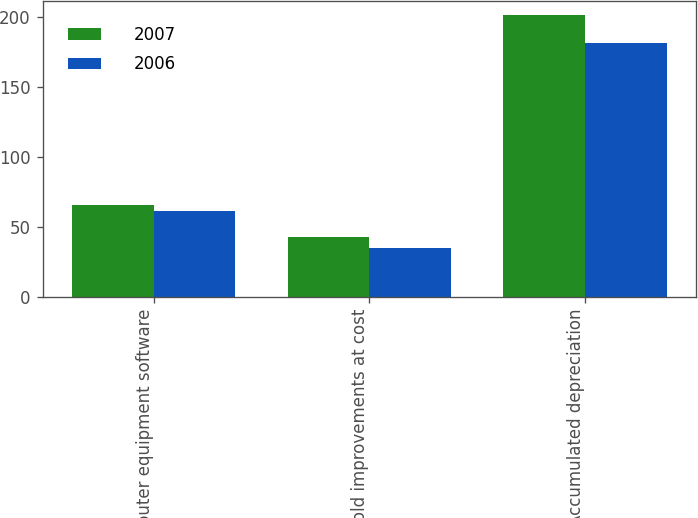<chart> <loc_0><loc_0><loc_500><loc_500><stacked_bar_chart><ecel><fcel>Computer equipment software<fcel>Leasehold improvements at cost<fcel>Less Accumulated depreciation<nl><fcel>2007<fcel>65.6<fcel>43<fcel>201.8<nl><fcel>2006<fcel>61.4<fcel>35<fcel>181.6<nl></chart> 